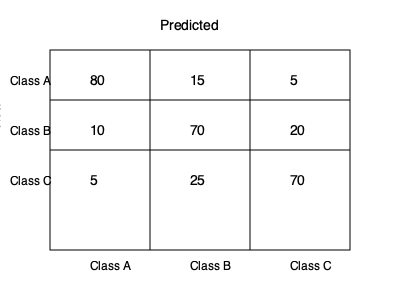Given the confusion matrix for a multi-class classification problem, calculate the overall accuracy of the model and the precision for Class B. To solve this problem, we'll follow these steps:

1. Calculate the overall accuracy:
   - Sum of correct predictions (diagonal elements) / Total predictions
   - Correct predictions: $80 + 70 + 70 = 220$
   - Total predictions: $80 + 15 + 5 + 10 + 70 + 20 + 5 + 25 + 70 = 300$
   - Accuracy = $\frac{220}{300} = \frac{11}{15} \approx 0.7333$ or $73.33\%$

2. Calculate the precision for Class B:
   - True positives for Class B / Total predicted as Class B
   - True positives for Class B: $70$
   - Total predicted as Class B: $15 + 70 + 25 = 110$
   - Precision for Class B = $\frac{70}{110} = \frac{7}{11} \approx 0.6364$ or $63.64\%$

The overall accuracy is the proportion of correct predictions across all classes, while precision for a specific class is the proportion of correct predictions for that class out of all instances predicted as that class.
Answer: Accuracy: $73.33\%$, Precision (Class B): $63.64\%$ 